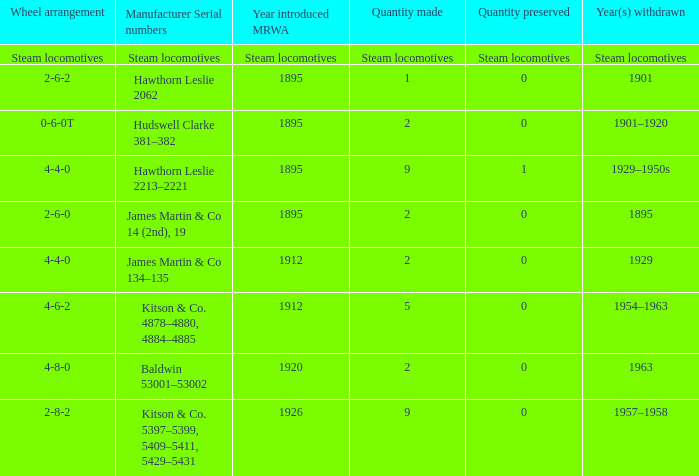What is the manufacturer serial number of the 1963 withdrawn year? Baldwin 53001–53002. 